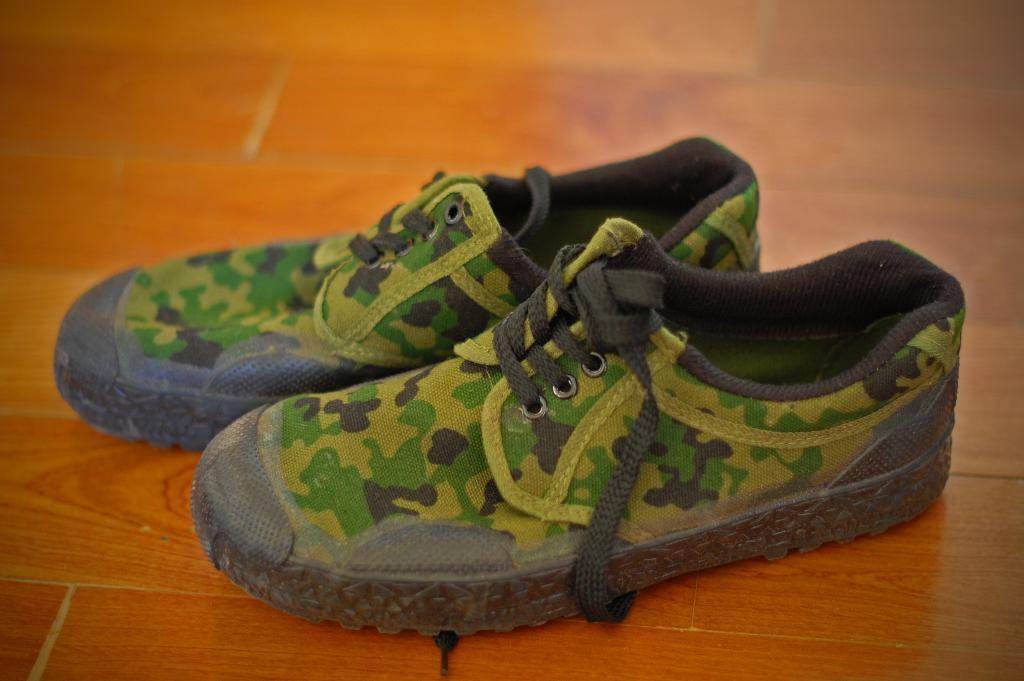What type of footwear is visible in the image? There are shoes in the image. What is the shoes resting on in the image? The shoes are on a wooden surface. What type of thunder can be heard in the image? There is no thunder present in the image, as it is a still image and cannot produce sound. 